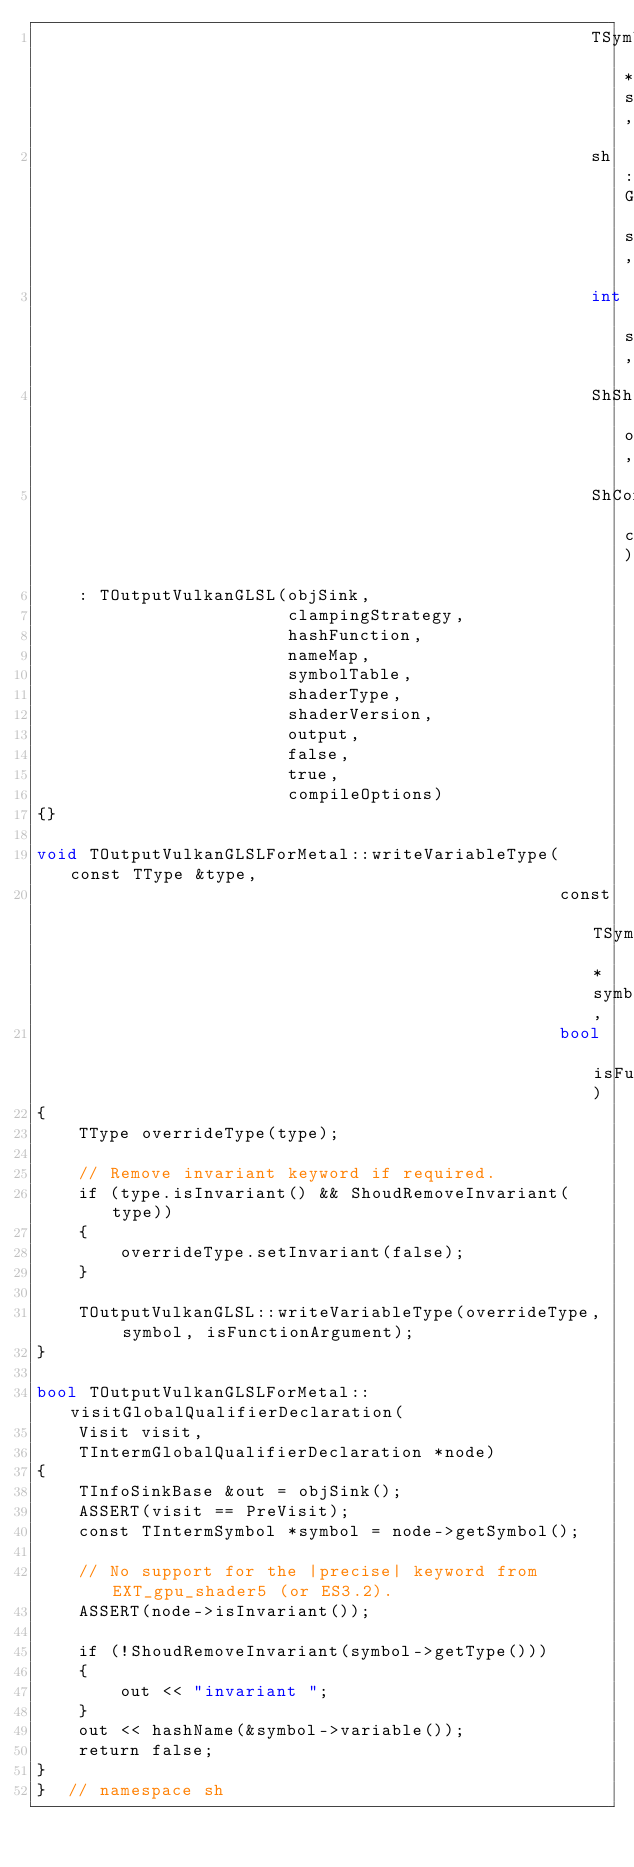Convert code to text. <code><loc_0><loc_0><loc_500><loc_500><_ObjectiveC_>                                                     TSymbolTable *symbolTable,
                                                     sh::GLenum shaderType,
                                                     int shaderVersion,
                                                     ShShaderOutput output,
                                                     ShCompileOptions compileOptions)
    : TOutputVulkanGLSL(objSink,
                        clampingStrategy,
                        hashFunction,
                        nameMap,
                        symbolTable,
                        shaderType,
                        shaderVersion,
                        output,
                        false,
                        true,
                        compileOptions)
{}

void TOutputVulkanGLSLForMetal::writeVariableType(const TType &type,
                                                  const TSymbol *symbol,
                                                  bool isFunctionArgument)
{
    TType overrideType(type);

    // Remove invariant keyword if required.
    if (type.isInvariant() && ShoudRemoveInvariant(type))
    {
        overrideType.setInvariant(false);
    }

    TOutputVulkanGLSL::writeVariableType(overrideType, symbol, isFunctionArgument);
}

bool TOutputVulkanGLSLForMetal::visitGlobalQualifierDeclaration(
    Visit visit,
    TIntermGlobalQualifierDeclaration *node)
{
    TInfoSinkBase &out = objSink();
    ASSERT(visit == PreVisit);
    const TIntermSymbol *symbol = node->getSymbol();

    // No support for the |precise| keyword from EXT_gpu_shader5 (or ES3.2).
    ASSERT(node->isInvariant());

    if (!ShoudRemoveInvariant(symbol->getType()))
    {
        out << "invariant ";
    }
    out << hashName(&symbol->variable());
    return false;
}
}  // namespace sh
</code> 